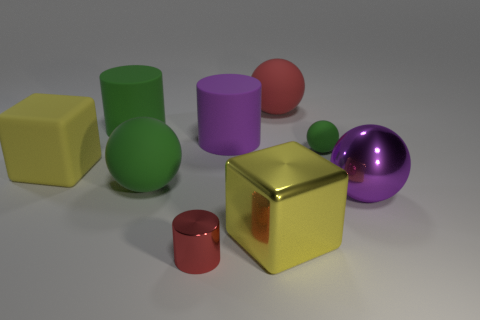What is the material of the cylinder that is the same color as the tiny ball?
Your response must be concise. Rubber. What color is the other big thing that is the same shape as the big purple matte thing?
Your response must be concise. Green. There is a large green matte object that is behind the small green matte object; is its shape the same as the red object that is in front of the large red sphere?
Provide a short and direct response. Yes. Are the large sphere on the left side of the red ball and the yellow cube to the right of the tiny shiny thing made of the same material?
Provide a succinct answer. No. What material is the red ball?
Keep it short and to the point. Rubber. Are there more big yellow blocks that are in front of the big purple metal object than green metal blocks?
Ensure brevity in your answer.  Yes. There is a green matte ball that is to the right of the red object that is behind the tiny red object; how many big green cylinders are right of it?
Provide a succinct answer. 0. There is a green thing that is on the right side of the big green matte cylinder and on the left side of the big red sphere; what is it made of?
Give a very brief answer. Rubber. The metal cylinder has what color?
Your response must be concise. Red. Are there more green rubber cylinders in front of the purple cylinder than green cylinders that are in front of the big yellow matte cube?
Ensure brevity in your answer.  No. 